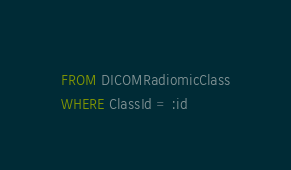Convert code to text. <code><loc_0><loc_0><loc_500><loc_500><_SQL_>FROM DICOMRadiomicClass
WHERE ClassId = :id</code> 